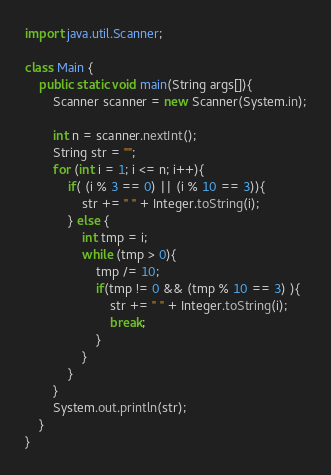<code> <loc_0><loc_0><loc_500><loc_500><_Java_>import java.util.Scanner;

class Main {
    public static void main(String args[]){
        Scanner scanner = new Scanner(System.in);
        
        int n = scanner.nextInt();
        String str = "";
        for (int i = 1; i <= n; i++){
            if( (i % 3 == 0) || (i % 10 == 3)){
                str += " " + Integer.toString(i);
            } else {
                int tmp = i;
                while (tmp > 0){
                    tmp /= 10;
                    if(tmp != 0 && (tmp % 10 == 3) ){
                        str += " " + Integer.toString(i);
                        break;
                    }
                }
            }
        }
        System.out.println(str);
    }
}
</code> 